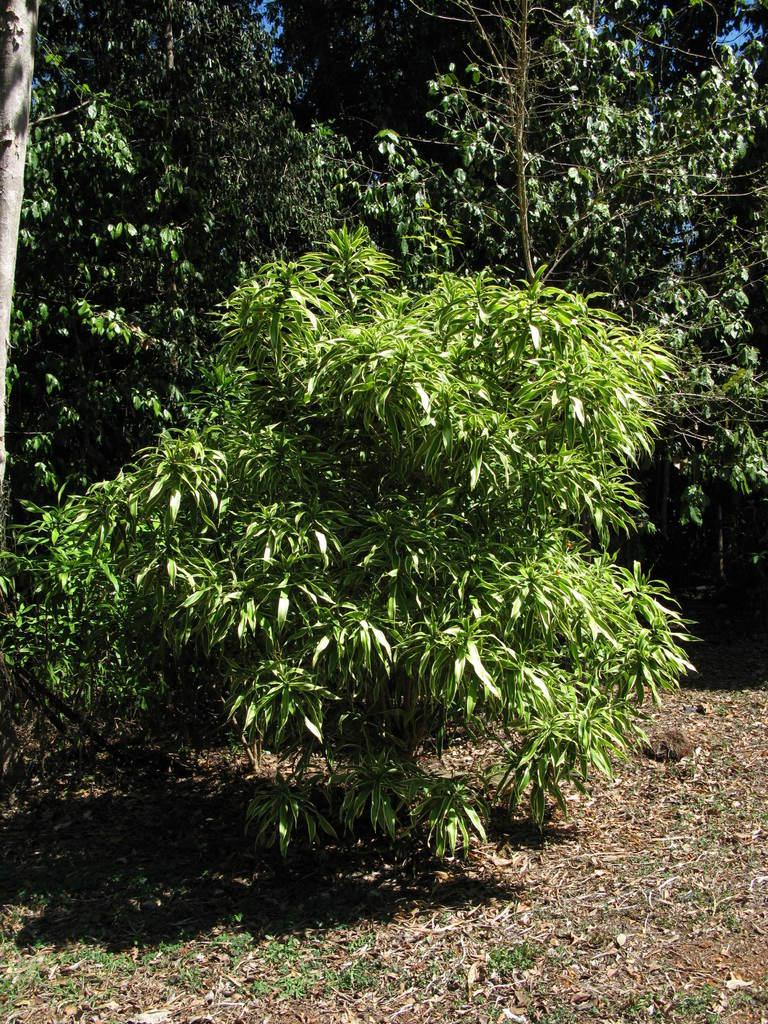What type of vegetation can be seen in the image? There are trees in the image. What is visible at the bottom of the image? There is ground visible at the bottom of the image. What type of door can be seen in the image? There is no door present in the image; it features trees and ground. What smell is associated with the trees in the image? The image does not provide any information about the smell of the trees, so it cannot be determined from the image. 